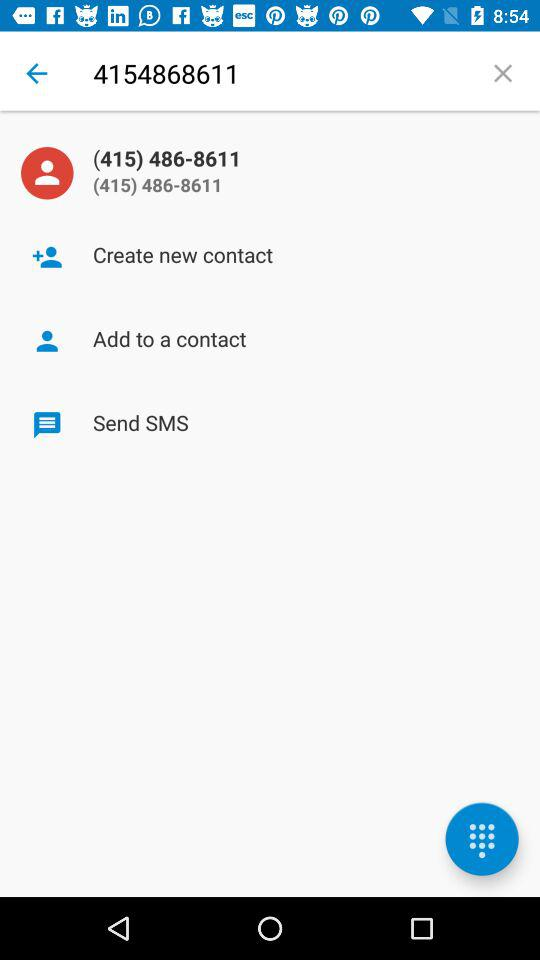What is the contact number? The contact number is (415) 486-8611. 